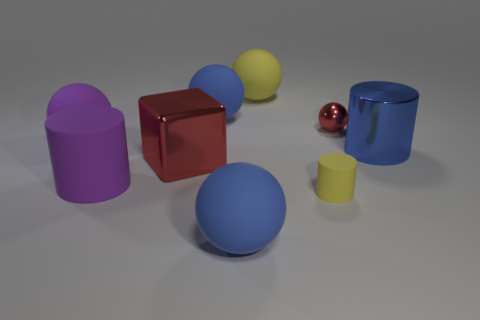There is a shiny object that is the same color as the tiny ball; what is its shape?
Your response must be concise. Cube. Does the tiny ball have the same color as the cube?
Offer a very short reply. Yes. Are there any purple things behind the red metal thing on the left side of the big yellow thing?
Make the answer very short. Yes. What number of blue things have the same material as the yellow cylinder?
Ensure brevity in your answer.  2. How big is the blue rubber thing that is behind the rubber cylinder that is to the left of the red metallic thing that is in front of the tiny red object?
Make the answer very short. Large. There is a small metal object; how many objects are on the right side of it?
Ensure brevity in your answer.  1. Are there more blocks than green shiny cubes?
Keep it short and to the point. Yes. There is a matte object that is the same color as the big matte cylinder; what is its size?
Your answer should be compact. Large. What is the size of the matte thing that is both in front of the big red thing and left of the large metallic cube?
Provide a short and direct response. Large. What is the material of the blue ball in front of the red metallic object that is left of the yellow matte object that is behind the red block?
Keep it short and to the point. Rubber. 